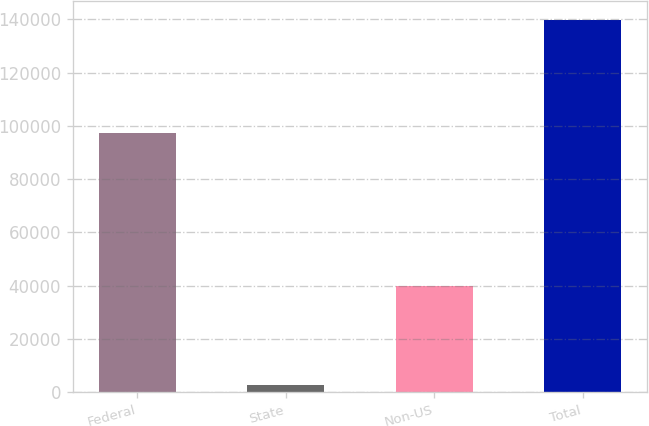Convert chart. <chart><loc_0><loc_0><loc_500><loc_500><bar_chart><fcel>Federal<fcel>State<fcel>Non-US<fcel>Total<nl><fcel>97438<fcel>2540<fcel>39850<fcel>139828<nl></chart> 